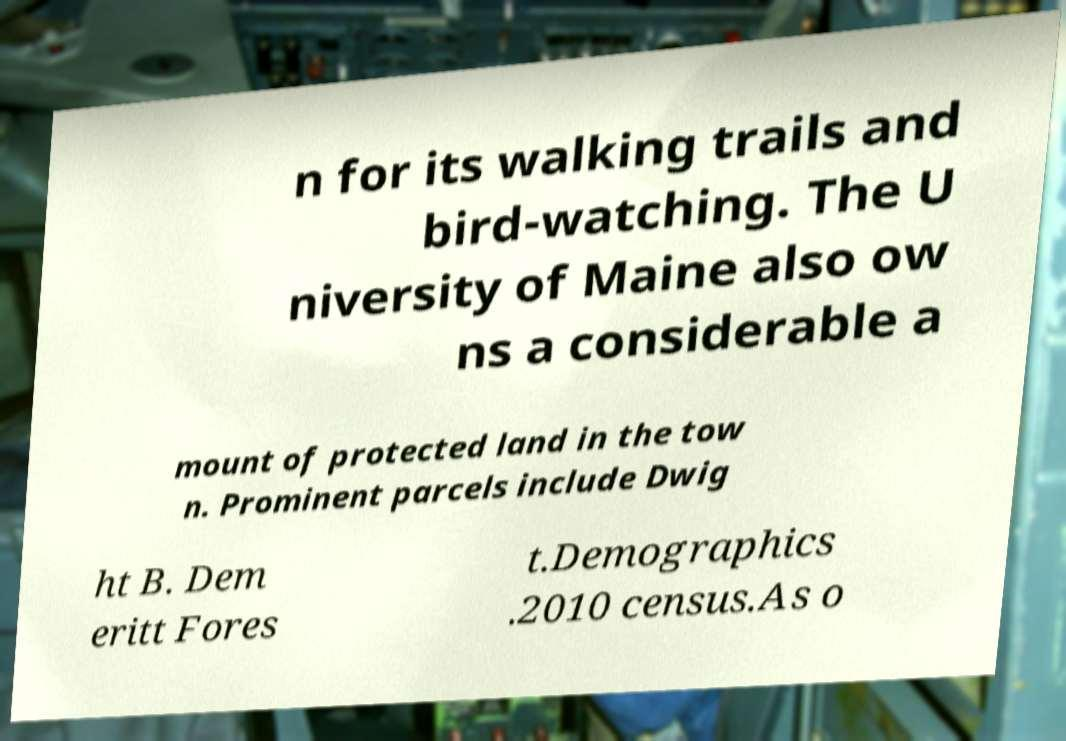Could you assist in decoding the text presented in this image and type it out clearly? n for its walking trails and bird-watching. The U niversity of Maine also ow ns a considerable a mount of protected land in the tow n. Prominent parcels include Dwig ht B. Dem eritt Fores t.Demographics .2010 census.As o 